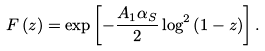<formula> <loc_0><loc_0><loc_500><loc_500>F \left ( z \right ) = \exp \left [ - \frac { A _ { 1 } \alpha _ { S } } { 2 } \log ^ { 2 } \left ( 1 - z \right ) \right ] .</formula> 